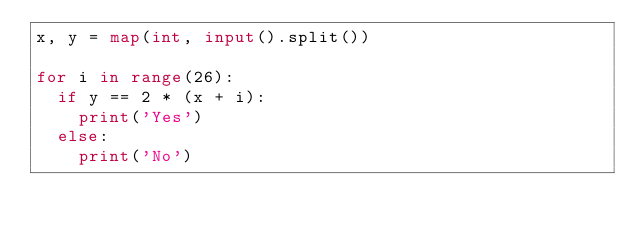Convert code to text. <code><loc_0><loc_0><loc_500><loc_500><_Python_>x, y = map(int, input().split())

for i in range(26):
  if y == 2 * (x + i):
    print('Yes')
  else:
    print('No')</code> 